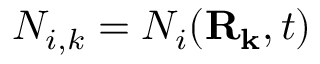<formula> <loc_0><loc_0><loc_500><loc_500>N _ { i , k } = N _ { i } ( \mathbf { R } _ { k } , t )</formula> 